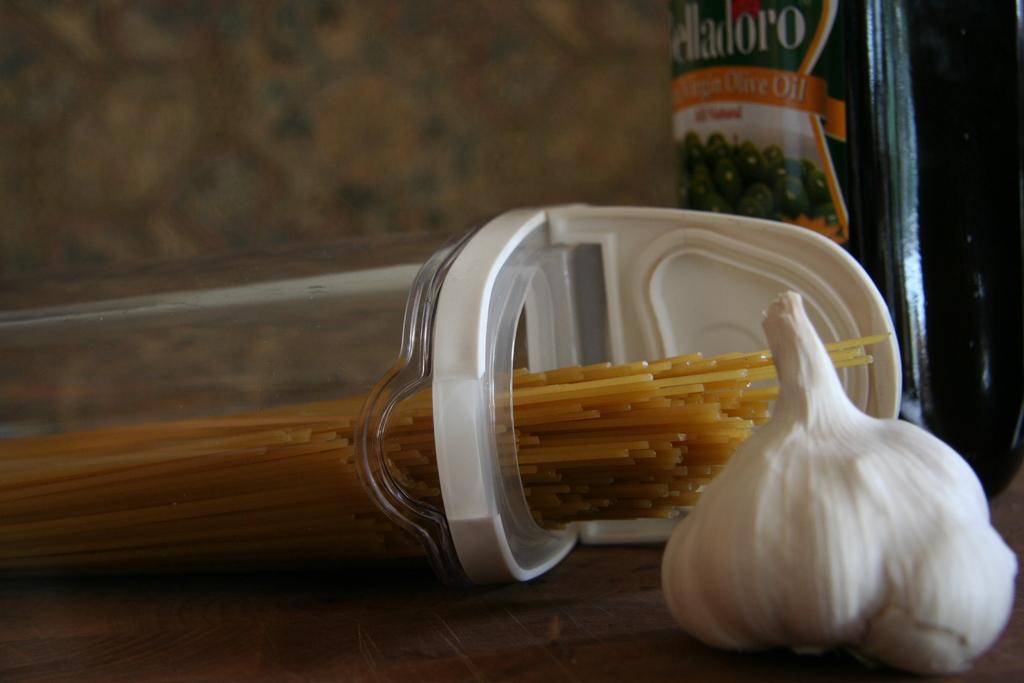In one or two sentences, can you explain what this image depicts? On this table there is a garlic, container, food packet and spaghetti. Background it is blur. 